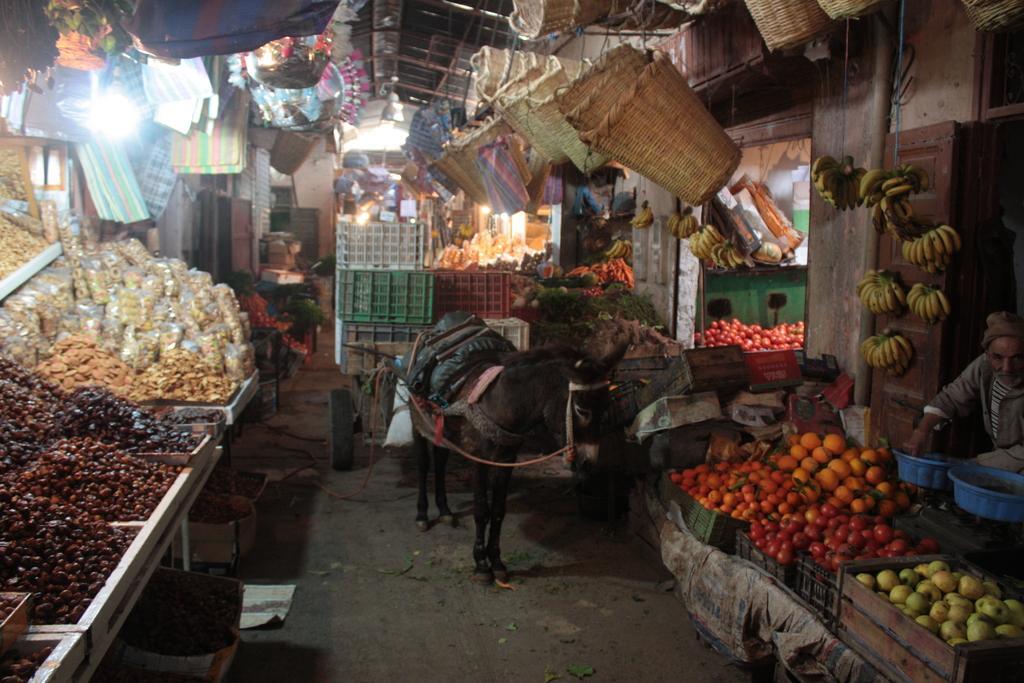Describe this image in one or two sentences. In this picture we can see a donkey in front of the store, and we can see a person, fruits, baskets, bags and lights. 